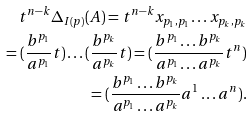Convert formula to latex. <formula><loc_0><loc_0><loc_500><loc_500>t ^ { n - k } \Delta _ { I ( p ) } ( A ) = t ^ { n - k } x _ { p _ { 1 } , p _ { 1 } } \dots x _ { p _ { k } , p _ { k } } \\ = ( \frac { b ^ { p _ { 1 } } } { a ^ { p _ { 1 } } } t ) \dots ( \frac { b ^ { p _ { k } } } { a ^ { p _ { k } } } t ) = ( \frac { b ^ { p _ { 1 } } \dots b ^ { p _ { k } } } { a ^ { p _ { 1 } } \dots a ^ { p _ { k } } } t ^ { n } ) \\ = ( \frac { b ^ { p _ { 1 } } \dots b ^ { p _ { k } } } { a ^ { p _ { 1 } } \dots a ^ { p _ { k } } } a ^ { 1 } \dots a ^ { n } ) .</formula> 